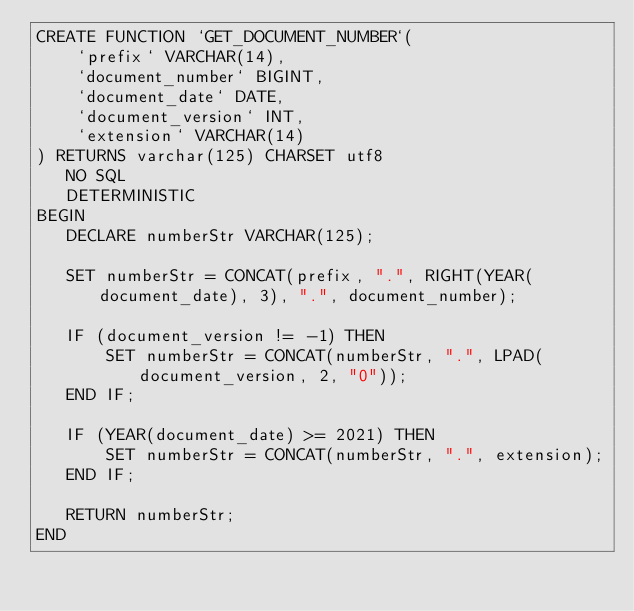Convert code to text. <code><loc_0><loc_0><loc_500><loc_500><_SQL_>CREATE FUNCTION `GET_DOCUMENT_NUMBER`(
    `prefix` VARCHAR(14),
    `document_number` BIGINT,
    `document_date` DATE,
    `document_version` INT,
    `extension` VARCHAR(14)
) RETURNS varchar(125) CHARSET utf8
   NO SQL
   DETERMINISTIC
BEGIN
   DECLARE numberStr VARCHAR(125);

   SET numberStr = CONCAT(prefix, ".", RIGHT(YEAR(document_date), 3), ".", document_number);

   IF (document_version != -1) THEN
       SET numberStr = CONCAT(numberStr, ".", LPAD(document_version, 2, "0"));
   END IF;

   IF (YEAR(document_date) >= 2021) THEN
       SET numberStr = CONCAT(numberStr, ".", extension);
   END IF;

   RETURN numberStr;
END</code> 